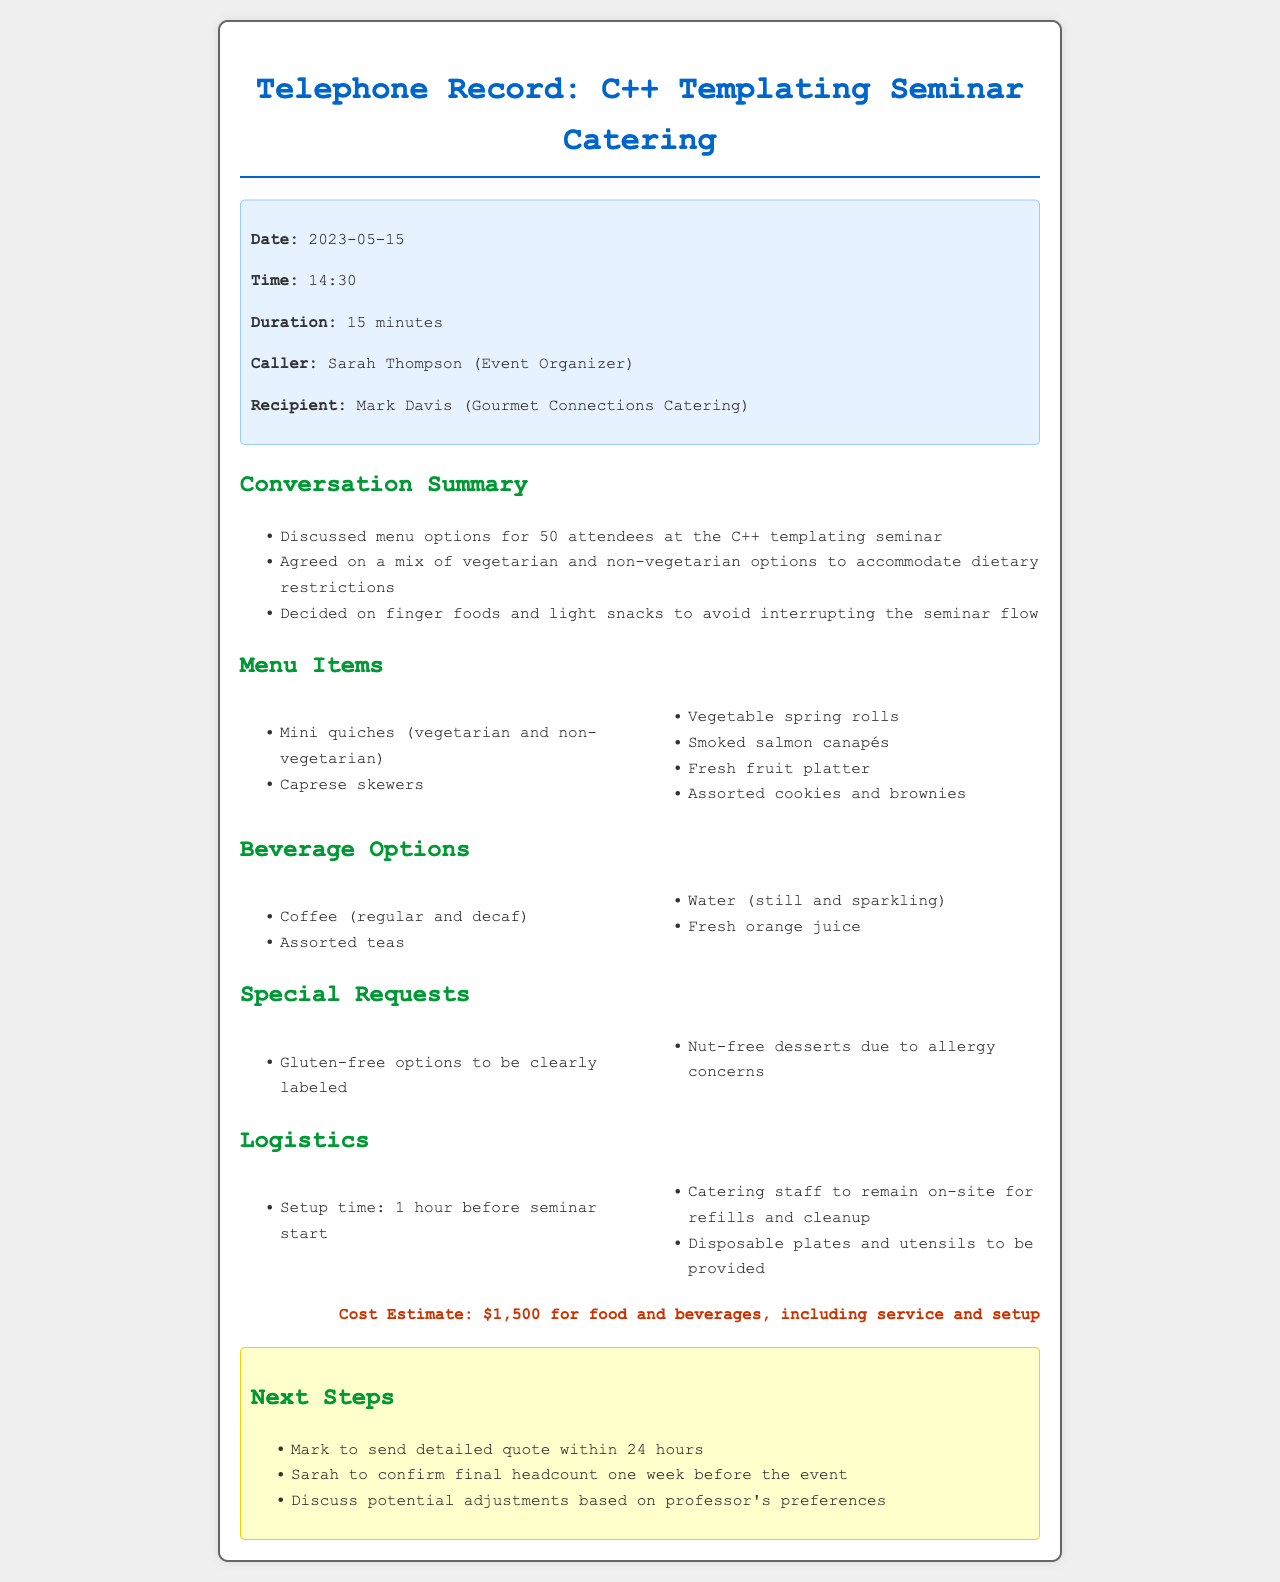What was the date of the phone call? The date of the phone call is specified in the call details section of the document.
Answer: 2023-05-15 Who was the caller? The caller's name is provided in the call details section, identifying the individual initiating the conversation.
Answer: Sarah Thompson How many attendees are expected at the seminar? The expected number of attendees is clearly mentioned in the conversation summary of the document.
Answer: 50 What is the estimated cost for food and beverages? The estimated cost is provided in the cost estimate section, summarizing the total expenses for catering.
Answer: $1,500 What type of food will be provided? The types of food are listed in the menu items section, detailing the various options available for attendees.
Answer: Mini quiches What special dietary requirement is mentioned? The special dietary requirement is specified in the special requests section, indicating a consideration for attendees with allergies.
Answer: Nut-free desserts How long before the seminar will setup begin? The setup time is mentioned in the logistics section, outlining the timing for preparing the catering.
Answer: 1 hour When will Mark send a detailed quote? The timeline for sending the quote is stated in the next steps section, indicating when the recipient will follow up.
Answer: Within 24 hours What will the catering staff do during the seminar? The responsibilities of the catering staff are outlined in the logistics section, clarifying their role during the event.
Answer: Remain on-site for refills and cleanup 